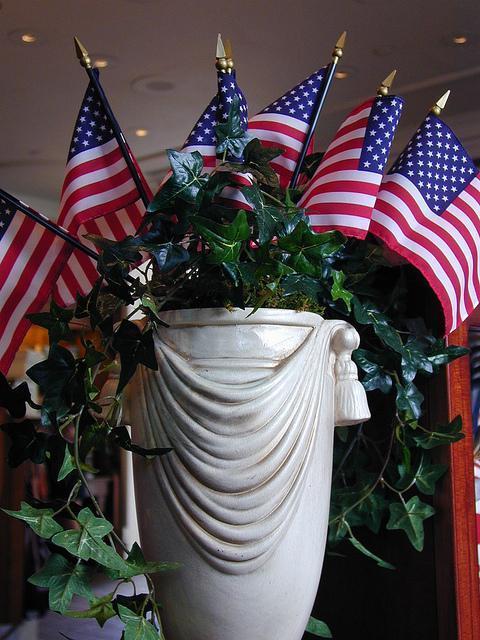How many red stripes does each flag have?
Give a very brief answer. 7. How many flags are there?
Give a very brief answer. 6. How many people are in this scene?
Give a very brief answer. 0. 